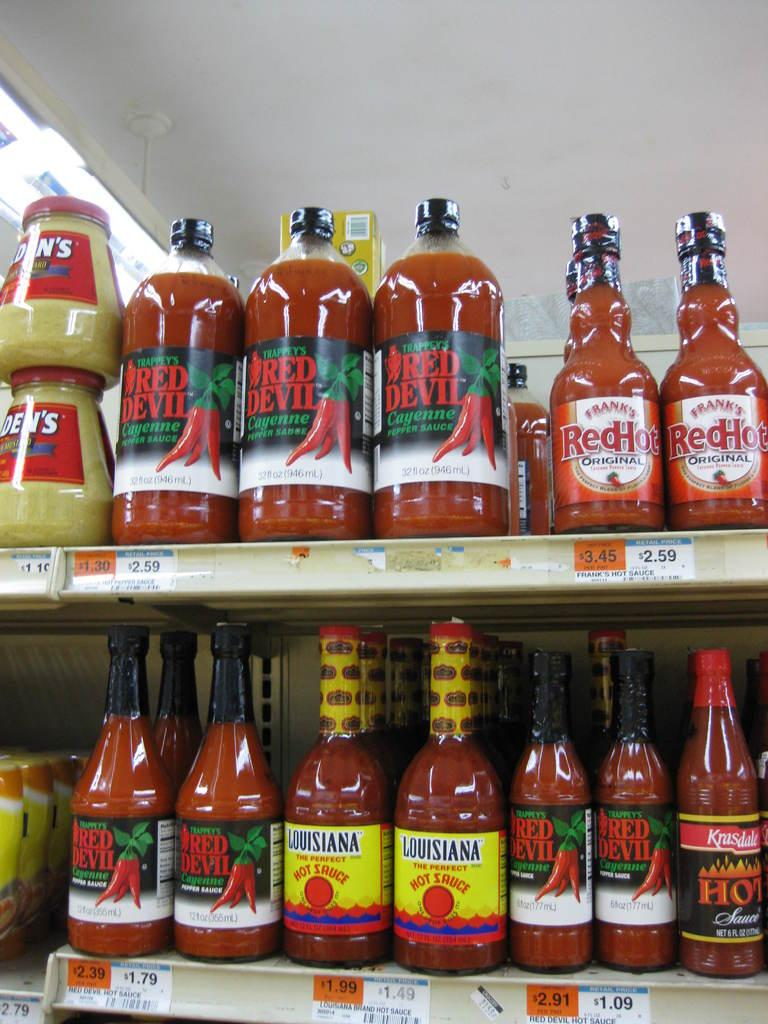What objects are on the rack in the image? There are bottles on a rack in the image. What can be seen in the background of the image? There is a wall in the image. What type of rock is visible on the wall in the image? There is no rock visible on the wall in the image; it is a plain wall. What sign is hanging from the wall in the image? There is no sign hanging from the wall in the image; it is just a plain wall. 